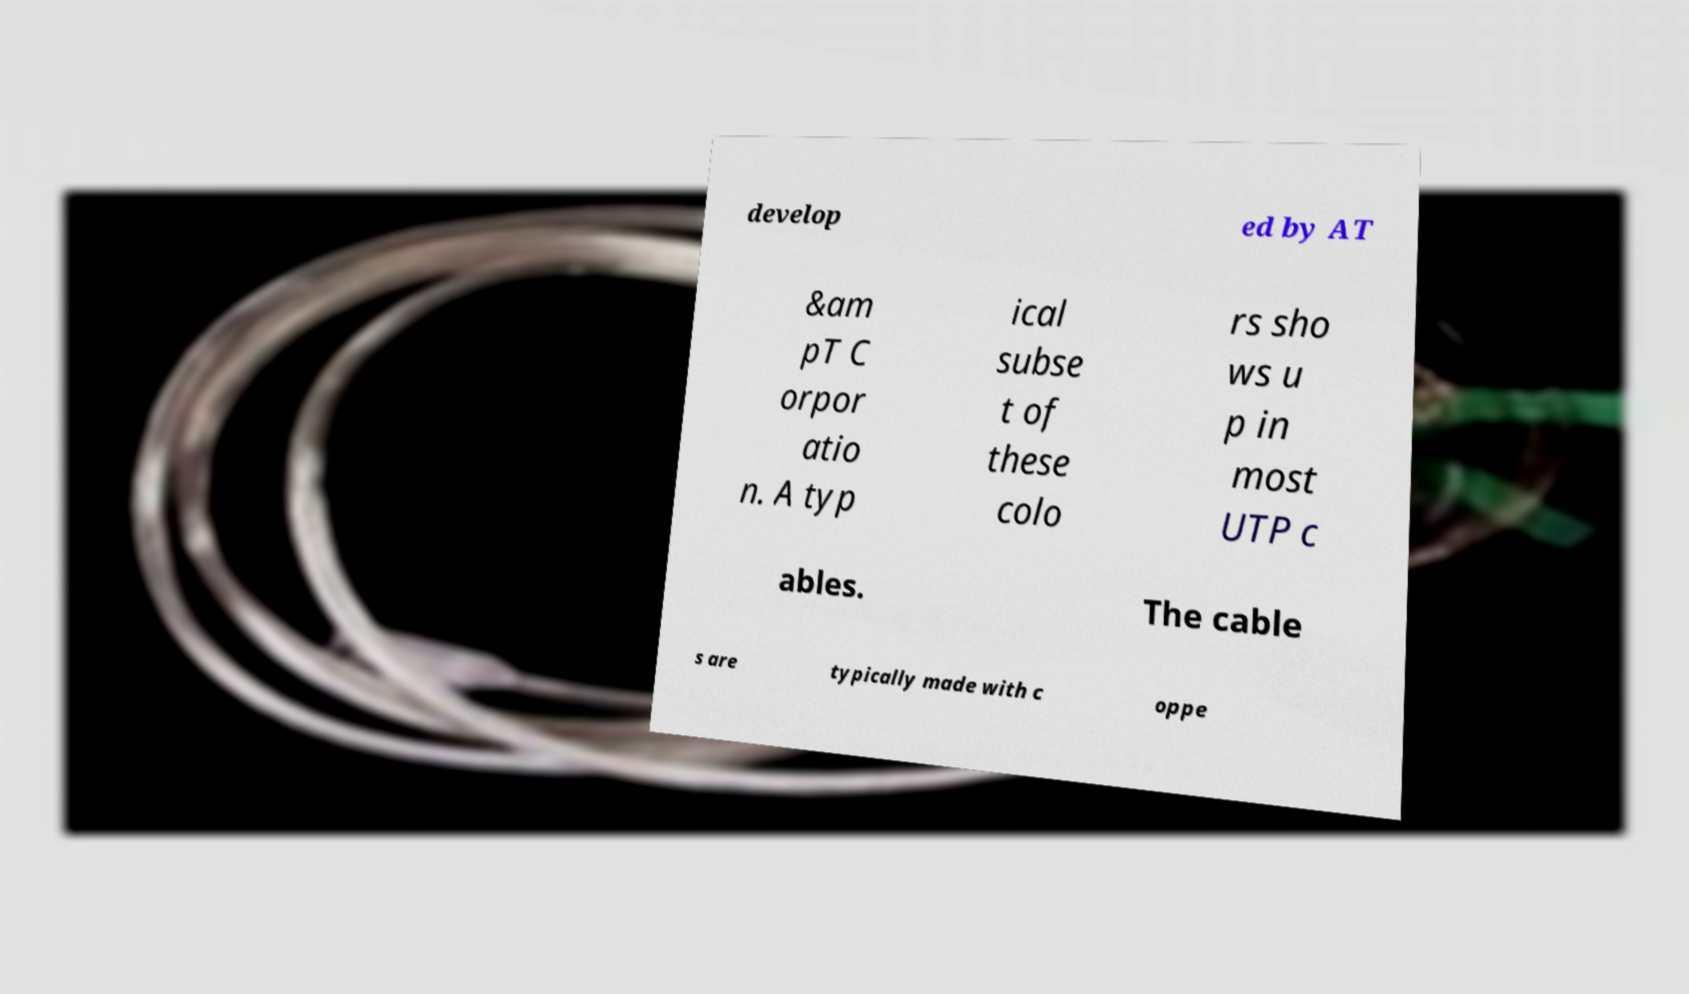For documentation purposes, I need the text within this image transcribed. Could you provide that? develop ed by AT &am pT C orpor atio n. A typ ical subse t of these colo rs sho ws u p in most UTP c ables. The cable s are typically made with c oppe 